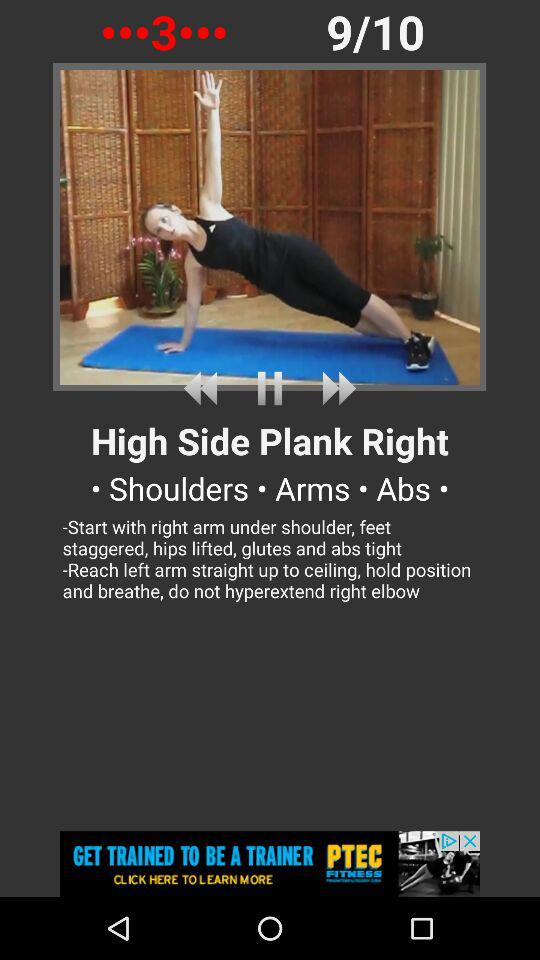Which exercise number are we currently on? You are at exercise number 9. 